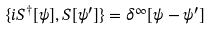<formula> <loc_0><loc_0><loc_500><loc_500>\{ i S ^ { \dagger } [ \psi ] , S [ \psi ^ { \prime } ] \} = \delta ^ { \infty } [ \psi - \psi ^ { \prime } ]</formula> 